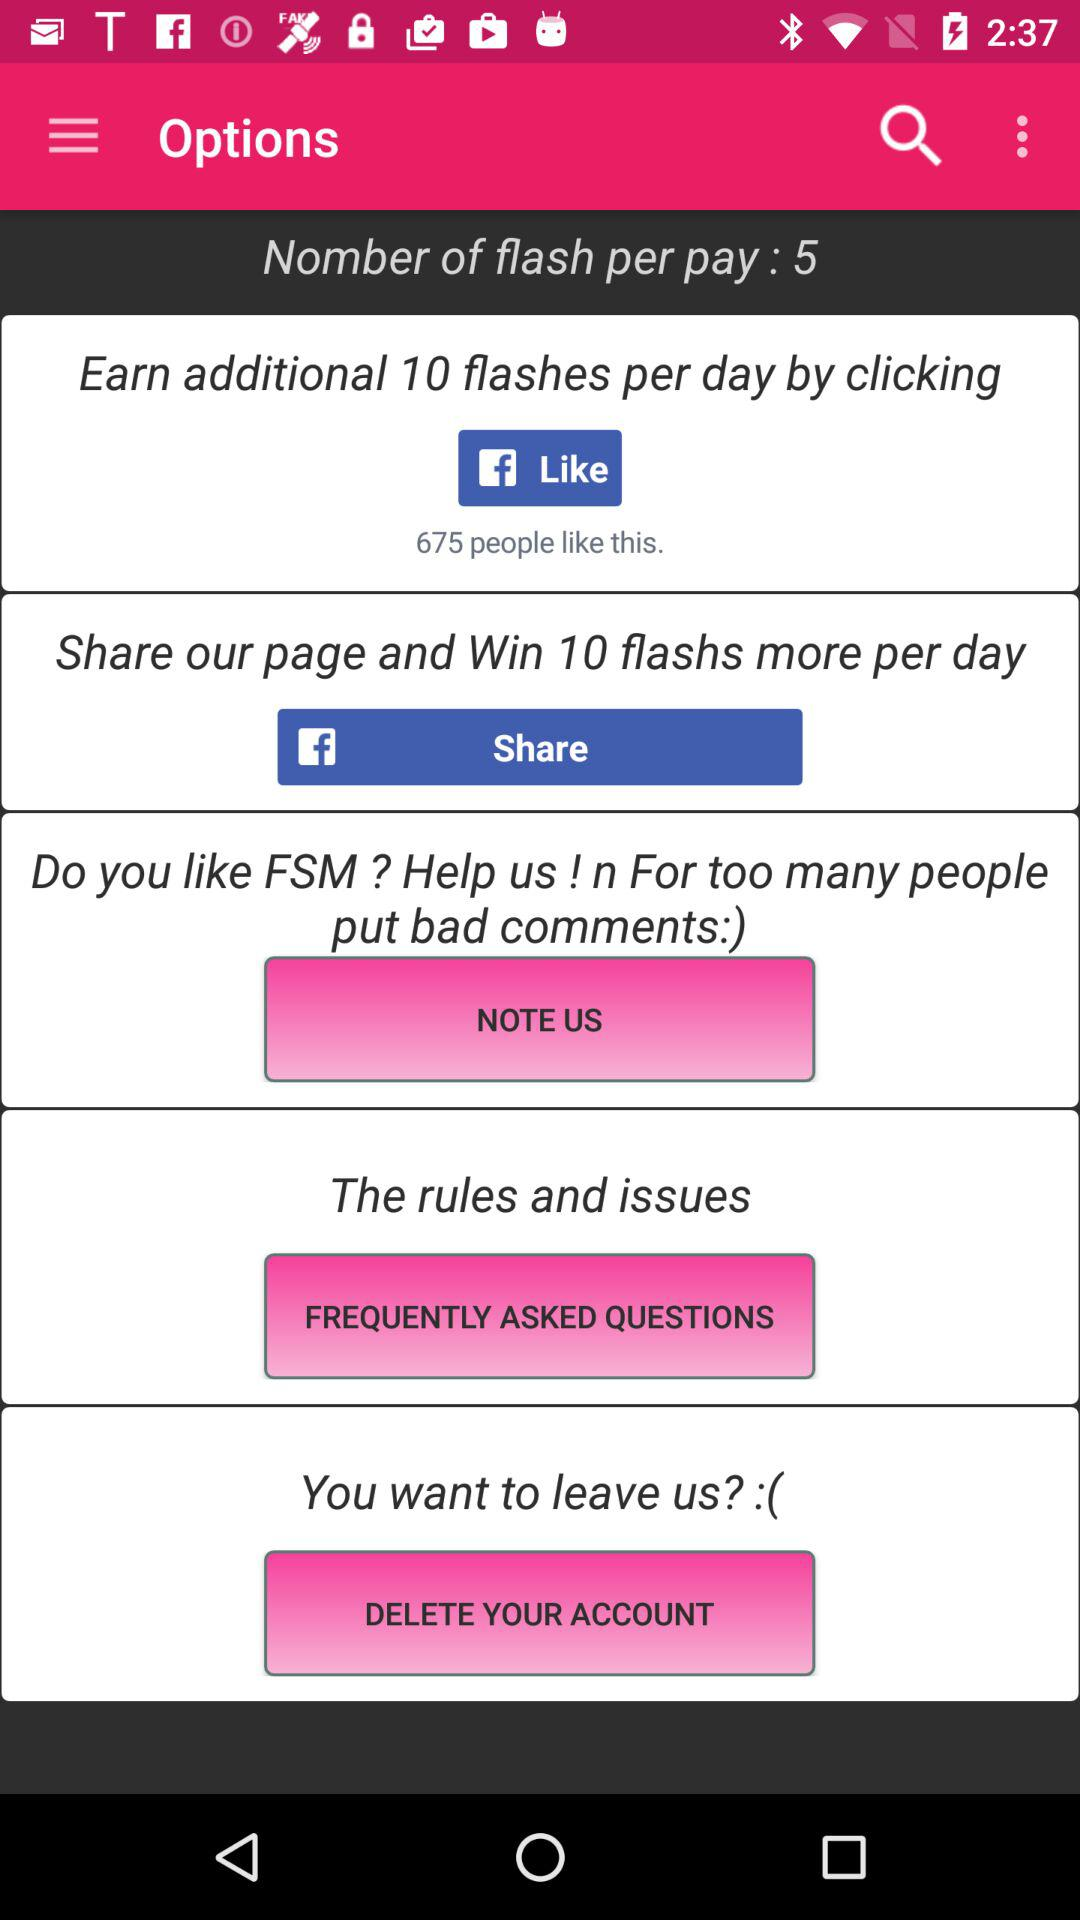What application can we use to share? You can share it on "Facebook". 